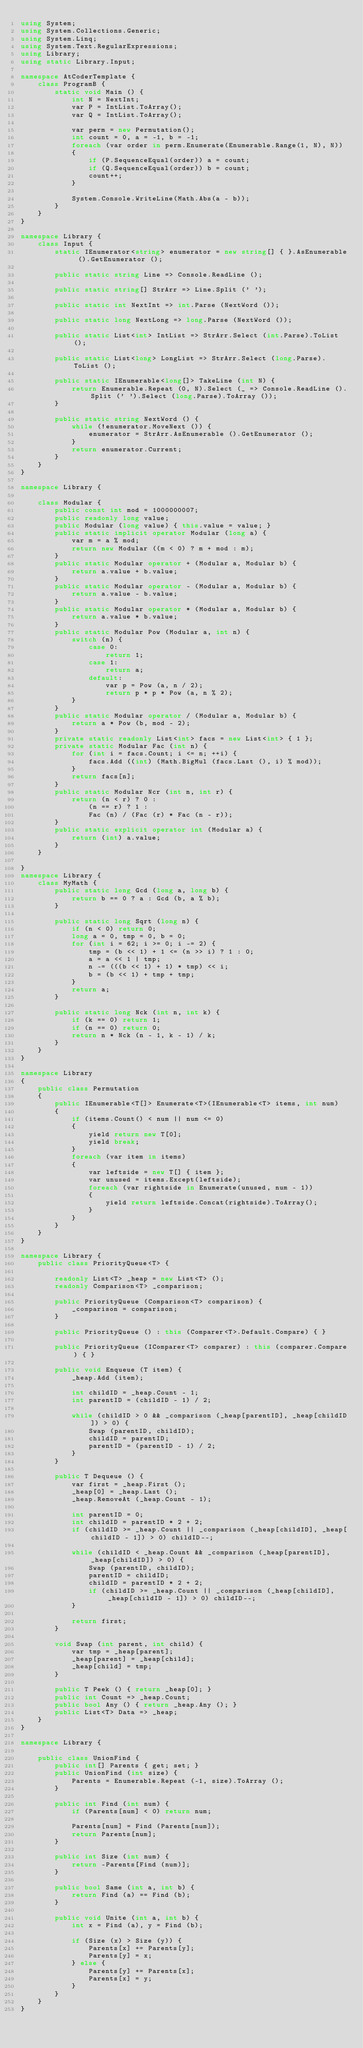Convert code to text. <code><loc_0><loc_0><loc_500><loc_500><_C#_>using System;
using System.Collections.Generic;
using System.Linq;
using System.Text.RegularExpressions;
using Library;
using static Library.Input;

namespace AtCoderTemplate {
    class ProgramB {
        static void Main () {
            int N = NextInt;
            var P = IntList.ToArray();
            var Q = IntList.ToArray();

            var perm = new Permutation();
            int count = 0, a = -1, b = -1;
            foreach (var order in perm.Enumerate(Enumerable.Range(1, N), N))
            {
                if (P.SequenceEqual(order)) a = count;
                if (Q.SequenceEqual(order)) b = count;
                count++;
            }

            System.Console.WriteLine(Math.Abs(a - b));
        }
    }
}

namespace Library {
    class Input {
        static IEnumerator<string> enumerator = new string[] { }.AsEnumerable ().GetEnumerator ();

        public static string Line => Console.ReadLine ();

        public static string[] StrArr => Line.Split (' ');

        public static int NextInt => int.Parse (NextWord ());

        public static long NextLong => long.Parse (NextWord ());

        public static List<int> IntList => StrArr.Select (int.Parse).ToList ();

        public static List<long> LongList => StrArr.Select (long.Parse).ToList ();

        public static IEnumerable<long[]> TakeLine (int N) {
            return Enumerable.Repeat (0, N).Select (_ => Console.ReadLine ().Split (' ').Select (long.Parse).ToArray ());
        }

        public static string NextWord () {
            while (!enumerator.MoveNext ()) {
                enumerator = StrArr.AsEnumerable ().GetEnumerator ();
            }
            return enumerator.Current;
        }
    }
}

namespace Library {
    
    class Modular {
        public const int mod = 1000000007;
        public readonly long value;
        public Modular (long value) { this.value = value; }
        public static implicit operator Modular (long a) {
            var m = a % mod;
            return new Modular ((m < 0) ? m + mod : m);
        }
        public static Modular operator + (Modular a, Modular b) {
            return a.value + b.value;
        }
        public static Modular operator - (Modular a, Modular b) {
            return a.value - b.value;
        }
        public static Modular operator * (Modular a, Modular b) {
            return a.value * b.value;
        }
        public static Modular Pow (Modular a, int n) {
            switch (n) {
                case 0:
                    return 1;
                case 1:
                    return a;
                default:
                    var p = Pow (a, n / 2);
                    return p * p * Pow (a, n % 2);
            }
        }
        public static Modular operator / (Modular a, Modular b) {
            return a * Pow (b, mod - 2);
        }
        private static readonly List<int> facs = new List<int> { 1 };
        private static Modular Fac (int n) {
            for (int i = facs.Count; i <= n; ++i) {
                facs.Add ((int) (Math.BigMul (facs.Last (), i) % mod));
            }
            return facs[n];
        }
        public static Modular Ncr (int n, int r) {
            return (n < r) ? 0 :
                (n == r) ? 1 :
                Fac (n) / (Fac (r) * Fac (n - r));
        }
        public static explicit operator int (Modular a) {
            return (int) a.value;
        }
    }

}
namespace Library {
    class MyMath {
        public static long Gcd (long a, long b) {
            return b == 0 ? a : Gcd (b, a % b);
        }

        public static long Sqrt (long n) {
            if (n < 0) return 0;
            long a = 0, tmp = 0, b = 0;
            for (int i = 62; i >= 0; i -= 2) {
                tmp = (b << 1) + 1 <= (n >> i) ? 1 : 0;
                a = a << 1 | tmp;
                n -= (((b << 1) + 1) * tmp) << i;
                b = (b << 1) + tmp + tmp;
            }
            return a;
        }

        public static long Nck (int n, int k) {
            if (k == 0) return 1;
            if (n == 0) return 0;
            return n * Nck (n - 1, k - 1) / k;
        }
    }
}

namespace Library
{
    public class Permutation
    {
        public IEnumerable<T[]> Enumerate<T>(IEnumerable<T> items, int num)
        {
            if (items.Count() < num || num <= 0)
            {
                yield return new T[0];
                yield break;
            }
            foreach (var item in items)
            {
                var leftside = new T[] { item };
                var unused = items.Except(leftside);
                foreach (var rightside in Enumerate(unused, num - 1))
                {
                    yield return leftside.Concat(rightside).ToArray();
                }
            }
        }
    }
}

namespace Library {
    public class PriorityQueue<T> {

        readonly List<T> _heap = new List<T> ();
        readonly Comparison<T> _comparison;

        public PriorityQueue (Comparison<T> comparison) {
            _comparison = comparison;
        }

        public PriorityQueue () : this (Comparer<T>.Default.Compare) { }

        public PriorityQueue (IComparer<T> comparer) : this (comparer.Compare) { }

        public void Enqueue (T item) {
            _heap.Add (item);

            int childID = _heap.Count - 1;
            int parentID = (childID - 1) / 2;

            while (childID > 0 && _comparison (_heap[parentID], _heap[childID]) > 0) {
                Swap (parentID, childID);
                childID = parentID;
                parentID = (parentID - 1) / 2;
            }
        }

        public T Dequeue () {
            var first = _heap.First ();
            _heap[0] = _heap.Last ();
            _heap.RemoveAt (_heap.Count - 1);

            int parentID = 0;
            int childID = parentID * 2 + 2;
            if (childID >= _heap.Count || _comparison (_heap[childID], _heap[childID - 1]) > 0) childID--;

            while (childID < _heap.Count && _comparison (_heap[parentID], _heap[childID]) > 0) {
                Swap (parentID, childID);
                parentID = childID;
                childID = parentID * 2 + 2;
                if (childID >= _heap.Count || _comparison (_heap[childID], _heap[childID - 1]) > 0) childID--;
            }

            return first;
        }

        void Swap (int parent, int child) {
            var tmp = _heap[parent];
            _heap[parent] = _heap[child];
            _heap[child] = tmp;
        }

        public T Peek () { return _heap[0]; }
        public int Count => _heap.Count;
        public bool Any () { return _heap.Any (); }
        public List<T> Data => _heap;
    }
}

namespace Library {
    
    public class UnionFind {
        public int[] Parents { get; set; }
        public UnionFind (int size) {
            Parents = Enumerable.Repeat (-1, size).ToArray ();
        }

        public int Find (int num) {
            if (Parents[num] < 0) return num;

            Parents[num] = Find (Parents[num]);
            return Parents[num];
        }

        public int Size (int num) {
            return -Parents[Find (num)];
        }

        public bool Same (int a, int b) {
            return Find (a) == Find (b);
        }

        public void Unite (int a, int b) {
            int x = Find (a), y = Find (b);

            if (Size (x) > Size (y)) {
                Parents[x] += Parents[y];
                Parents[y] = x;
            } else {
                Parents[y] += Parents[x];
                Parents[x] = y;
            }
        }
    }
}
</code> 